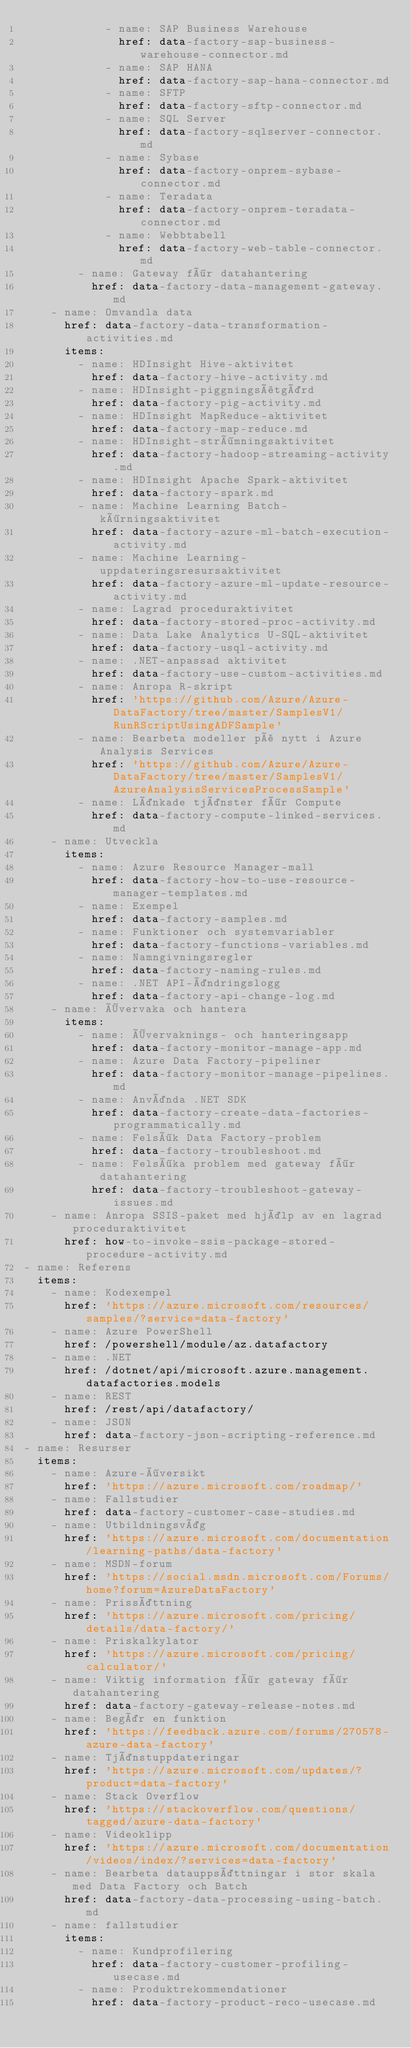<code> <loc_0><loc_0><loc_500><loc_500><_YAML_>            - name: SAP Business Warehouse
              href: data-factory-sap-business-warehouse-connector.md
            - name: SAP HANA
              href: data-factory-sap-hana-connector.md
            - name: SFTP
              href: data-factory-sftp-connector.md
            - name: SQL Server
              href: data-factory-sqlserver-connector.md
            - name: Sybase
              href: data-factory-onprem-sybase-connector.md
            - name: Teradata
              href: data-factory-onprem-teradata-connector.md
            - name: Webbtabell
              href: data-factory-web-table-connector.md
        - name: Gateway för datahantering
          href: data-factory-data-management-gateway.md
    - name: Omvandla data
      href: data-factory-data-transformation-activities.md
      items:
        - name: HDInsight Hive-aktivitet
          href: data-factory-hive-activity.md
        - name: HDInsight-piggningsåtgärd
          href: data-factory-pig-activity.md
        - name: HDInsight MapReduce-aktivitet
          href: data-factory-map-reduce.md
        - name: HDInsight-strömningsaktivitet
          href: data-factory-hadoop-streaming-activity.md
        - name: HDInsight Apache Spark-aktivitet
          href: data-factory-spark.md
        - name: Machine Learning Batch-körningsaktivitet
          href: data-factory-azure-ml-batch-execution-activity.md
        - name: Machine Learning-uppdateringsresursaktivitet
          href: data-factory-azure-ml-update-resource-activity.md
        - name: Lagrad proceduraktivitet
          href: data-factory-stored-proc-activity.md
        - name: Data Lake Analytics U-SQL-aktivitet
          href: data-factory-usql-activity.md
        - name: .NET-anpassad aktivitet
          href: data-factory-use-custom-activities.md
        - name: Anropa R-skript
          href: 'https://github.com/Azure/Azure-DataFactory/tree/master/SamplesV1/RunRScriptUsingADFSample'
        - name: Bearbeta modeller på nytt i Azure Analysis Services
          href: 'https://github.com/Azure/Azure-DataFactory/tree/master/SamplesV1/AzureAnalysisServicesProcessSample'
        - name: Länkade tjänster för Compute
          href: data-factory-compute-linked-services.md
    - name: Utveckla
      items:
        - name: Azure Resource Manager-mall
          href: data-factory-how-to-use-resource-manager-templates.md
        - name: Exempel
          href: data-factory-samples.md
        - name: Funktioner och systemvariabler
          href: data-factory-functions-variables.md
        - name: Namngivningsregler
          href: data-factory-naming-rules.md
        - name: .NET API-ändringslogg
          href: data-factory-api-change-log.md
    - name: Övervaka och hantera
      items:
        - name: Övervaknings- och hanteringsapp
          href: data-factory-monitor-manage-app.md
        - name: Azure Data Factory-pipeliner
          href: data-factory-monitor-manage-pipelines.md
        - name: Använda .NET SDK
          href: data-factory-create-data-factories-programmatically.md
        - name: Felsök Data Factory-problem
          href: data-factory-troubleshoot.md
        - name: Felsöka problem med gateway för datahantering
          href: data-factory-troubleshoot-gateway-issues.md
    - name: Anropa SSIS-paket med hjälp av en lagrad proceduraktivitet
      href: how-to-invoke-ssis-package-stored-procedure-activity.md
- name: Referens
  items:
    - name: Kodexempel
      href: 'https://azure.microsoft.com/resources/samples/?service=data-factory'
    - name: Azure PowerShell
      href: /powershell/module/az.datafactory
    - name: .NET
      href: /dotnet/api/microsoft.azure.management.datafactories.models
    - name: REST
      href: /rest/api/datafactory/
    - name: JSON
      href: data-factory-json-scripting-reference.md
- name: Resurser
  items:
    - name: Azure-översikt
      href: 'https://azure.microsoft.com/roadmap/'
    - name: Fallstudier
      href: data-factory-customer-case-studies.md
    - name: Utbildningsväg
      href: 'https://azure.microsoft.com/documentation/learning-paths/data-factory'
    - name: MSDN-forum
      href: 'https://social.msdn.microsoft.com/Forums/home?forum=AzureDataFactory'
    - name: Prissättning
      href: 'https://azure.microsoft.com/pricing/details/data-factory/'
    - name: Priskalkylator
      href: 'https://azure.microsoft.com/pricing/calculator/'
    - name: Viktig information för gateway för datahantering
      href: data-factory-gateway-release-notes.md
    - name: Begär en funktion
      href: 'https://feedback.azure.com/forums/270578-azure-data-factory'
    - name: Tjänstuppdateringar
      href: 'https://azure.microsoft.com/updates/?product=data-factory'
    - name: Stack Overflow
      href: 'https://stackoverflow.com/questions/tagged/azure-data-factory'
    - name: Videoklipp
      href: 'https://azure.microsoft.com/documentation/videos/index/?services=data-factory'
    - name: Bearbeta datauppsättningar i stor skala med Data Factory och Batch
      href: data-factory-data-processing-using-batch.md
    - name: fallstudier
      items:
        - name: Kundprofilering
          href: data-factory-customer-profiling-usecase.md
        - name: Produktrekommendationer
          href: data-factory-product-reco-usecase.md</code> 